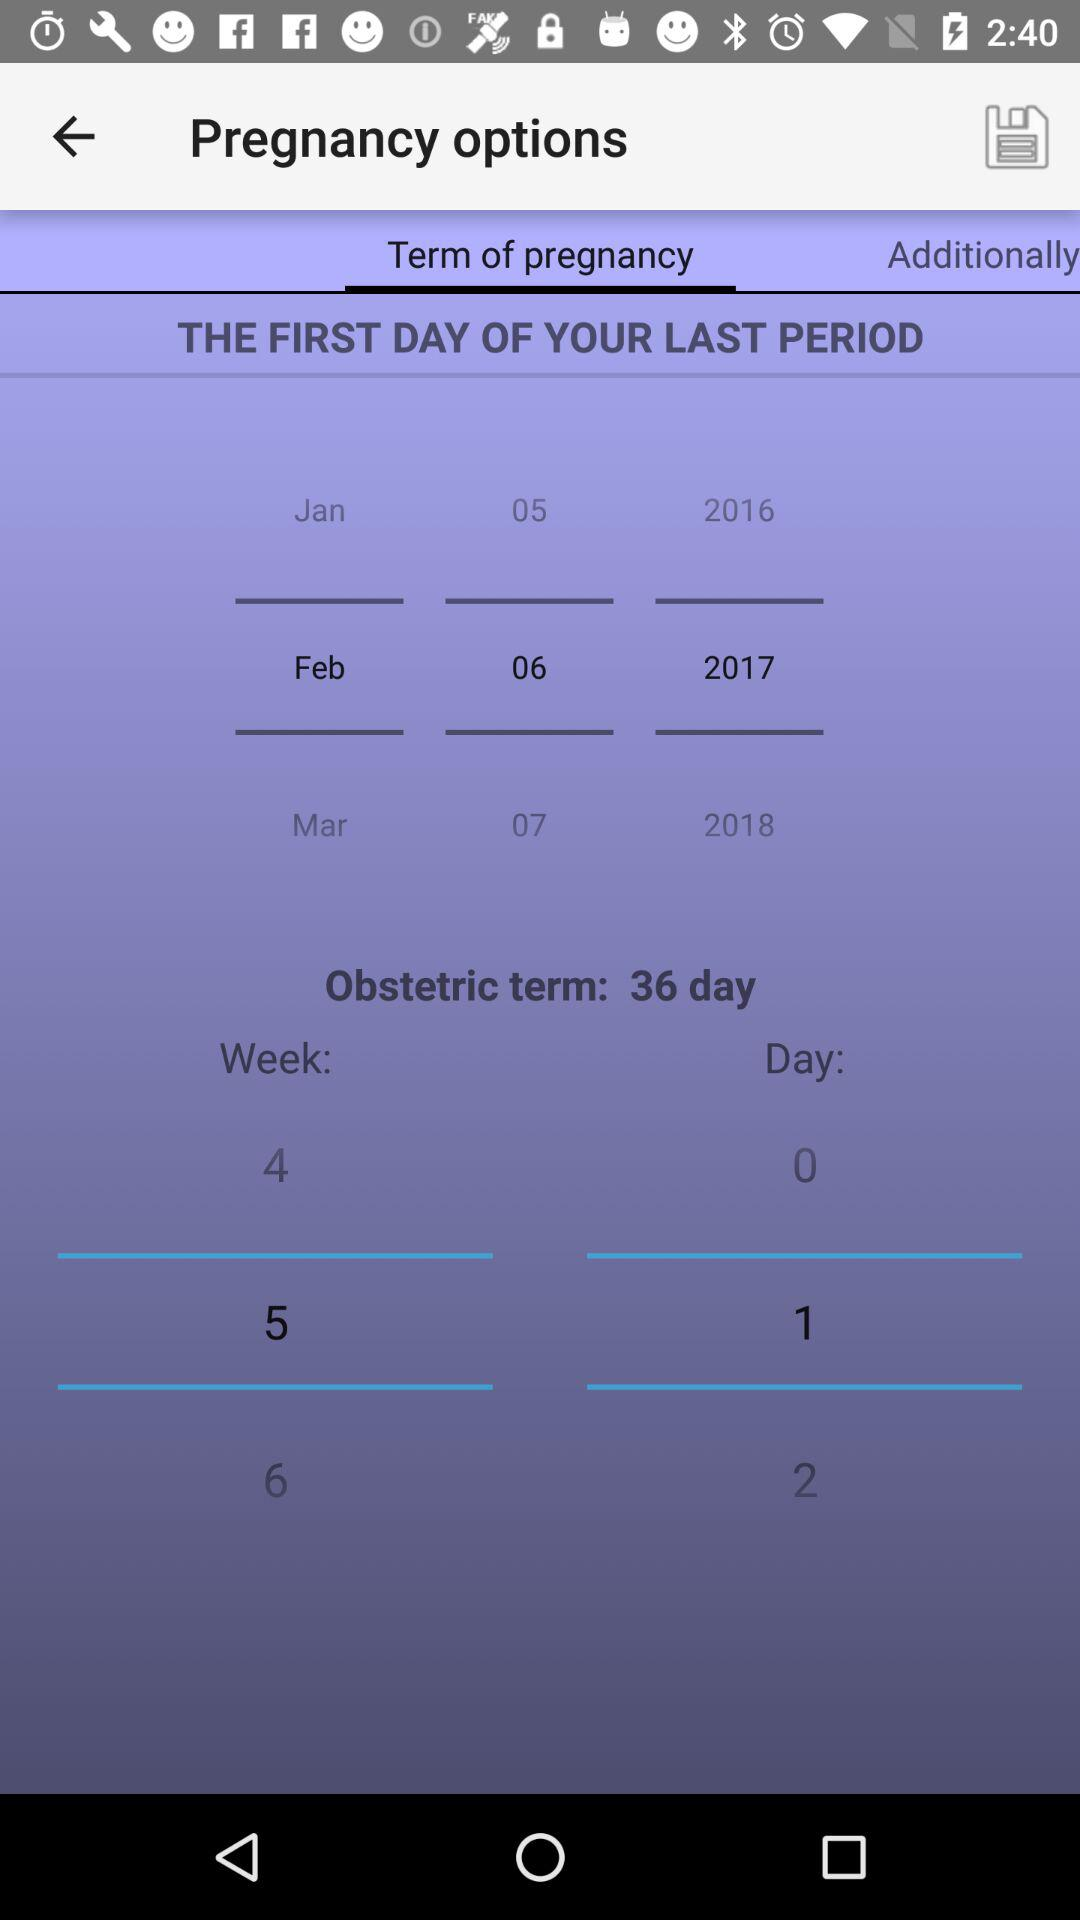Which week is selected? The selected week is 5. 